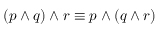<formula> <loc_0><loc_0><loc_500><loc_500>( p \wedge q ) \wedge r \equiv p \wedge ( q \wedge r )</formula> 